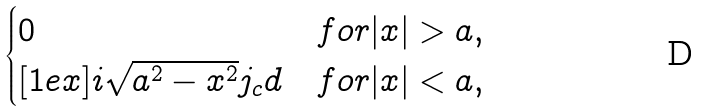<formula> <loc_0><loc_0><loc_500><loc_500>\begin{cases} 0 & f o r | x | > a , \\ [ 1 e x ] i \sqrt { a ^ { 2 } - x ^ { 2 } } j _ { c } d & f o r | x | < a , \end{cases}</formula> 